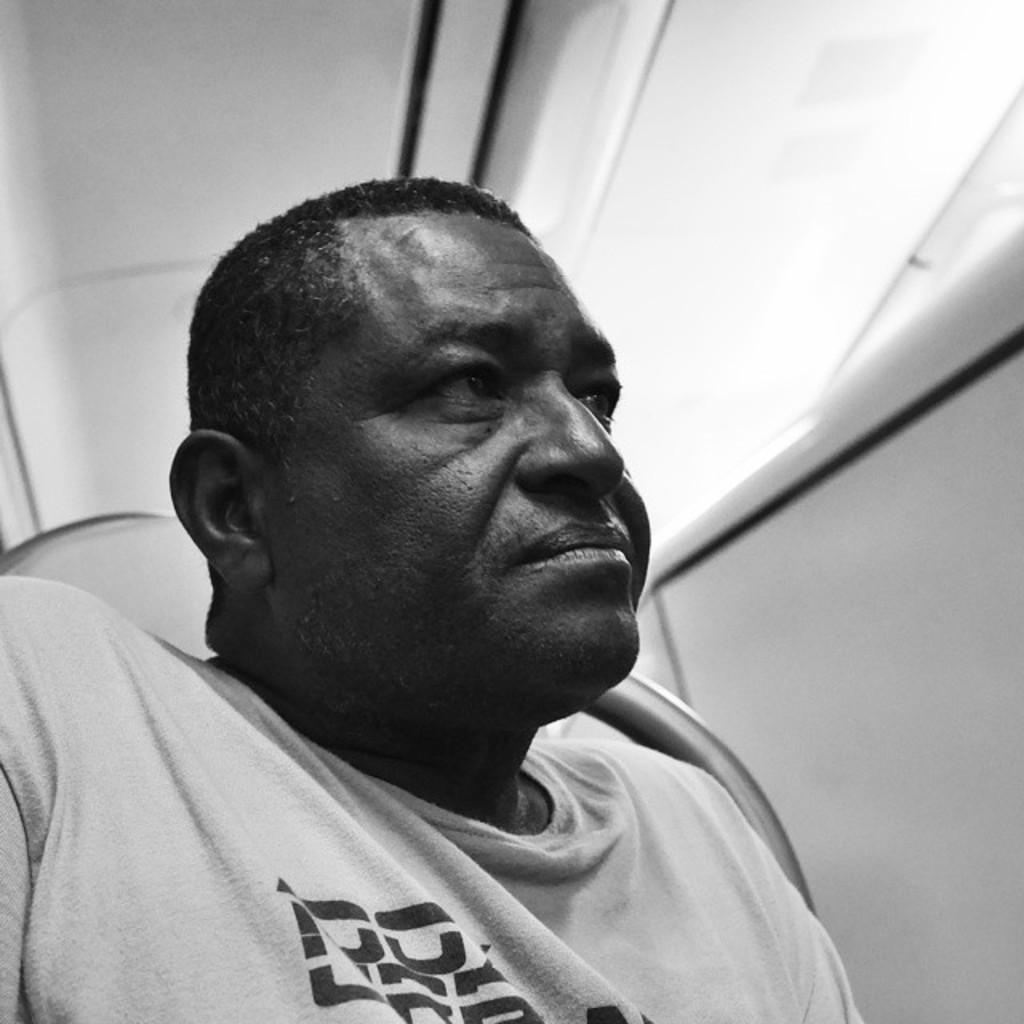What is the color scheme of the image? The image is black and white. What can be seen in the image besides the color scheme? There is a person sitting on a chair in the image. What type of structure is visible in the image? There is a wall and a roof visible in the image. What type of pleasure can be seen being enjoyed by the passenger in the playground in the image? There is no passenger or playground present in the image; it features a person sitting on a chair in a black and white setting. 